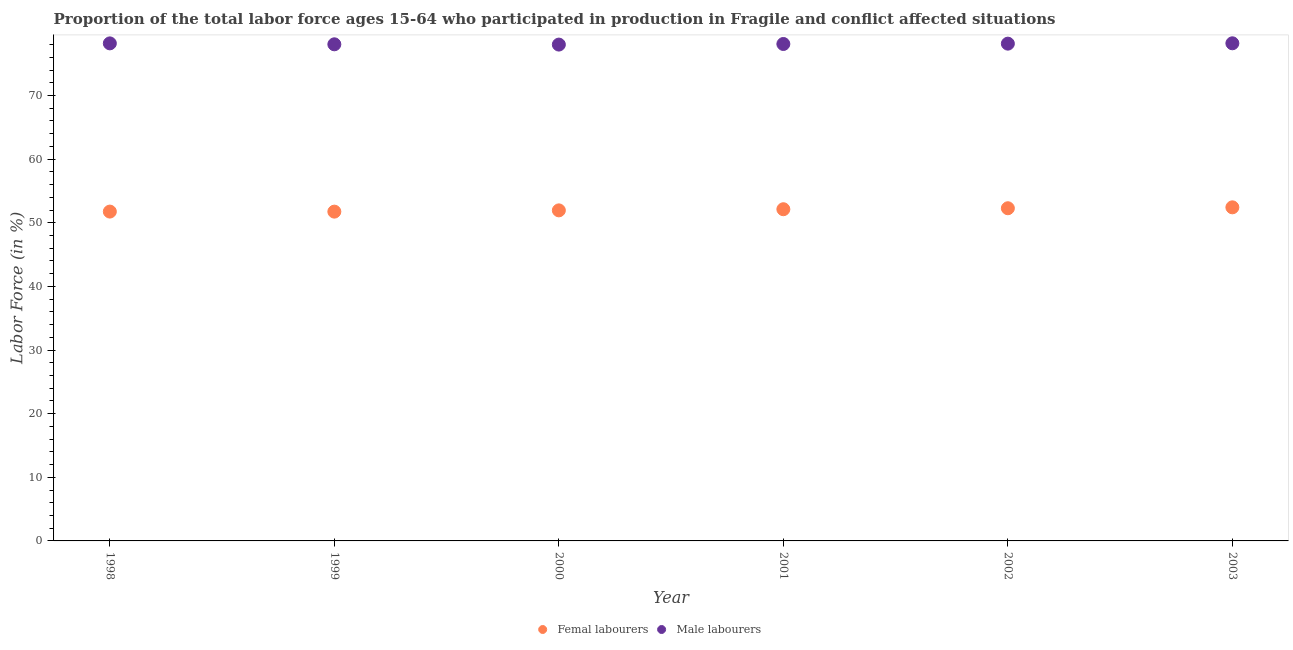Is the number of dotlines equal to the number of legend labels?
Offer a terse response. Yes. What is the percentage of female labor force in 1998?
Ensure brevity in your answer.  51.76. Across all years, what is the maximum percentage of female labor force?
Your answer should be compact. 52.43. Across all years, what is the minimum percentage of female labor force?
Your response must be concise. 51.75. What is the total percentage of male labour force in the graph?
Offer a terse response. 468.72. What is the difference between the percentage of male labour force in 1999 and that in 2003?
Ensure brevity in your answer.  -0.16. What is the difference between the percentage of male labour force in 2002 and the percentage of female labor force in 1998?
Make the answer very short. 26.4. What is the average percentage of male labour force per year?
Your answer should be very brief. 78.12. In the year 1999, what is the difference between the percentage of male labour force and percentage of female labor force?
Your answer should be very brief. 26.3. What is the ratio of the percentage of male labour force in 1998 to that in 2001?
Give a very brief answer. 1. What is the difference between the highest and the second highest percentage of male labour force?
Offer a very short reply. 0.01. What is the difference between the highest and the lowest percentage of male labour force?
Provide a short and direct response. 0.2. In how many years, is the percentage of male labour force greater than the average percentage of male labour force taken over all years?
Your response must be concise. 3. How many dotlines are there?
Make the answer very short. 2. How many years are there in the graph?
Your answer should be compact. 6. Does the graph contain any zero values?
Provide a succinct answer. No. Does the graph contain grids?
Provide a short and direct response. No. Where does the legend appear in the graph?
Your response must be concise. Bottom center. What is the title of the graph?
Provide a succinct answer. Proportion of the total labor force ages 15-64 who participated in production in Fragile and conflict affected situations. What is the Labor Force (in %) in Femal labourers in 1998?
Your response must be concise. 51.76. What is the Labor Force (in %) in Male labourers in 1998?
Offer a terse response. 78.2. What is the Labor Force (in %) of Femal labourers in 1999?
Your response must be concise. 51.75. What is the Labor Force (in %) in Male labourers in 1999?
Provide a succinct answer. 78.05. What is the Labor Force (in %) of Femal labourers in 2000?
Keep it short and to the point. 51.95. What is the Labor Force (in %) in Male labourers in 2000?
Your answer should be very brief. 78.01. What is the Labor Force (in %) in Femal labourers in 2001?
Ensure brevity in your answer.  52.13. What is the Labor Force (in %) of Male labourers in 2001?
Give a very brief answer. 78.1. What is the Labor Force (in %) of Femal labourers in 2002?
Give a very brief answer. 52.29. What is the Labor Force (in %) in Male labourers in 2002?
Give a very brief answer. 78.16. What is the Labor Force (in %) of Femal labourers in 2003?
Give a very brief answer. 52.43. What is the Labor Force (in %) in Male labourers in 2003?
Offer a terse response. 78.21. Across all years, what is the maximum Labor Force (in %) in Femal labourers?
Make the answer very short. 52.43. Across all years, what is the maximum Labor Force (in %) in Male labourers?
Provide a succinct answer. 78.21. Across all years, what is the minimum Labor Force (in %) in Femal labourers?
Make the answer very short. 51.75. Across all years, what is the minimum Labor Force (in %) in Male labourers?
Provide a succinct answer. 78.01. What is the total Labor Force (in %) of Femal labourers in the graph?
Keep it short and to the point. 312.31. What is the total Labor Force (in %) of Male labourers in the graph?
Your answer should be very brief. 468.72. What is the difference between the Labor Force (in %) in Femal labourers in 1998 and that in 1999?
Provide a succinct answer. 0.01. What is the difference between the Labor Force (in %) in Male labourers in 1998 and that in 1999?
Give a very brief answer. 0.15. What is the difference between the Labor Force (in %) of Femal labourers in 1998 and that in 2000?
Keep it short and to the point. -0.19. What is the difference between the Labor Force (in %) in Male labourers in 1998 and that in 2000?
Make the answer very short. 0.19. What is the difference between the Labor Force (in %) of Femal labourers in 1998 and that in 2001?
Keep it short and to the point. -0.37. What is the difference between the Labor Force (in %) in Male labourers in 1998 and that in 2001?
Offer a very short reply. 0.1. What is the difference between the Labor Force (in %) in Femal labourers in 1998 and that in 2002?
Offer a terse response. -0.53. What is the difference between the Labor Force (in %) of Male labourers in 1998 and that in 2002?
Your response must be concise. 0.04. What is the difference between the Labor Force (in %) of Femal labourers in 1998 and that in 2003?
Provide a short and direct response. -0.67. What is the difference between the Labor Force (in %) of Male labourers in 1998 and that in 2003?
Offer a very short reply. -0.01. What is the difference between the Labor Force (in %) of Femal labourers in 1999 and that in 2000?
Your answer should be compact. -0.2. What is the difference between the Labor Force (in %) in Male labourers in 1999 and that in 2000?
Keep it short and to the point. 0.04. What is the difference between the Labor Force (in %) of Femal labourers in 1999 and that in 2001?
Your answer should be very brief. -0.38. What is the difference between the Labor Force (in %) in Male labourers in 1999 and that in 2001?
Keep it short and to the point. -0.05. What is the difference between the Labor Force (in %) of Femal labourers in 1999 and that in 2002?
Provide a short and direct response. -0.53. What is the difference between the Labor Force (in %) in Male labourers in 1999 and that in 2002?
Offer a very short reply. -0.1. What is the difference between the Labor Force (in %) in Femal labourers in 1999 and that in 2003?
Make the answer very short. -0.68. What is the difference between the Labor Force (in %) of Male labourers in 1999 and that in 2003?
Provide a short and direct response. -0.16. What is the difference between the Labor Force (in %) in Femal labourers in 2000 and that in 2001?
Offer a very short reply. -0.18. What is the difference between the Labor Force (in %) in Male labourers in 2000 and that in 2001?
Your answer should be compact. -0.09. What is the difference between the Labor Force (in %) of Femal labourers in 2000 and that in 2002?
Keep it short and to the point. -0.33. What is the difference between the Labor Force (in %) in Male labourers in 2000 and that in 2002?
Your response must be concise. -0.15. What is the difference between the Labor Force (in %) of Femal labourers in 2000 and that in 2003?
Provide a succinct answer. -0.48. What is the difference between the Labor Force (in %) of Male labourers in 2000 and that in 2003?
Make the answer very short. -0.2. What is the difference between the Labor Force (in %) in Femal labourers in 2001 and that in 2002?
Your response must be concise. -0.15. What is the difference between the Labor Force (in %) in Male labourers in 2001 and that in 2002?
Your answer should be very brief. -0.05. What is the difference between the Labor Force (in %) in Femal labourers in 2001 and that in 2003?
Keep it short and to the point. -0.3. What is the difference between the Labor Force (in %) in Male labourers in 2001 and that in 2003?
Make the answer very short. -0.11. What is the difference between the Labor Force (in %) of Femal labourers in 2002 and that in 2003?
Offer a terse response. -0.14. What is the difference between the Labor Force (in %) in Male labourers in 2002 and that in 2003?
Give a very brief answer. -0.05. What is the difference between the Labor Force (in %) in Femal labourers in 1998 and the Labor Force (in %) in Male labourers in 1999?
Provide a succinct answer. -26.29. What is the difference between the Labor Force (in %) in Femal labourers in 1998 and the Labor Force (in %) in Male labourers in 2000?
Keep it short and to the point. -26.25. What is the difference between the Labor Force (in %) in Femal labourers in 1998 and the Labor Force (in %) in Male labourers in 2001?
Ensure brevity in your answer.  -26.34. What is the difference between the Labor Force (in %) in Femal labourers in 1998 and the Labor Force (in %) in Male labourers in 2002?
Give a very brief answer. -26.4. What is the difference between the Labor Force (in %) in Femal labourers in 1998 and the Labor Force (in %) in Male labourers in 2003?
Ensure brevity in your answer.  -26.45. What is the difference between the Labor Force (in %) of Femal labourers in 1999 and the Labor Force (in %) of Male labourers in 2000?
Give a very brief answer. -26.25. What is the difference between the Labor Force (in %) in Femal labourers in 1999 and the Labor Force (in %) in Male labourers in 2001?
Offer a very short reply. -26.35. What is the difference between the Labor Force (in %) in Femal labourers in 1999 and the Labor Force (in %) in Male labourers in 2002?
Your answer should be compact. -26.4. What is the difference between the Labor Force (in %) in Femal labourers in 1999 and the Labor Force (in %) in Male labourers in 2003?
Your answer should be very brief. -26.46. What is the difference between the Labor Force (in %) of Femal labourers in 2000 and the Labor Force (in %) of Male labourers in 2001?
Your answer should be very brief. -26.15. What is the difference between the Labor Force (in %) of Femal labourers in 2000 and the Labor Force (in %) of Male labourers in 2002?
Make the answer very short. -26.2. What is the difference between the Labor Force (in %) in Femal labourers in 2000 and the Labor Force (in %) in Male labourers in 2003?
Ensure brevity in your answer.  -26.26. What is the difference between the Labor Force (in %) in Femal labourers in 2001 and the Labor Force (in %) in Male labourers in 2002?
Provide a short and direct response. -26.02. What is the difference between the Labor Force (in %) of Femal labourers in 2001 and the Labor Force (in %) of Male labourers in 2003?
Offer a very short reply. -26.08. What is the difference between the Labor Force (in %) in Femal labourers in 2002 and the Labor Force (in %) in Male labourers in 2003?
Give a very brief answer. -25.93. What is the average Labor Force (in %) in Femal labourers per year?
Give a very brief answer. 52.05. What is the average Labor Force (in %) in Male labourers per year?
Your response must be concise. 78.12. In the year 1998, what is the difference between the Labor Force (in %) of Femal labourers and Labor Force (in %) of Male labourers?
Make the answer very short. -26.44. In the year 1999, what is the difference between the Labor Force (in %) in Femal labourers and Labor Force (in %) in Male labourers?
Make the answer very short. -26.3. In the year 2000, what is the difference between the Labor Force (in %) of Femal labourers and Labor Force (in %) of Male labourers?
Ensure brevity in your answer.  -26.06. In the year 2001, what is the difference between the Labor Force (in %) of Femal labourers and Labor Force (in %) of Male labourers?
Keep it short and to the point. -25.97. In the year 2002, what is the difference between the Labor Force (in %) of Femal labourers and Labor Force (in %) of Male labourers?
Ensure brevity in your answer.  -25.87. In the year 2003, what is the difference between the Labor Force (in %) in Femal labourers and Labor Force (in %) in Male labourers?
Keep it short and to the point. -25.78. What is the ratio of the Labor Force (in %) of Male labourers in 1998 to that in 1999?
Keep it short and to the point. 1. What is the ratio of the Labor Force (in %) of Femal labourers in 1998 to that in 2000?
Offer a very short reply. 1. What is the ratio of the Labor Force (in %) of Femal labourers in 1998 to that in 2003?
Your answer should be compact. 0.99. What is the ratio of the Labor Force (in %) of Male labourers in 1998 to that in 2003?
Ensure brevity in your answer.  1. What is the ratio of the Labor Force (in %) of Femal labourers in 1999 to that in 2000?
Make the answer very short. 1. What is the ratio of the Labor Force (in %) of Male labourers in 1999 to that in 2002?
Ensure brevity in your answer.  1. What is the ratio of the Labor Force (in %) of Femal labourers in 1999 to that in 2003?
Offer a terse response. 0.99. What is the ratio of the Labor Force (in %) in Male labourers in 2000 to that in 2001?
Keep it short and to the point. 1. What is the ratio of the Labor Force (in %) of Male labourers in 2000 to that in 2002?
Make the answer very short. 1. What is the ratio of the Labor Force (in %) of Femal labourers in 2000 to that in 2003?
Make the answer very short. 0.99. What is the ratio of the Labor Force (in %) in Femal labourers in 2001 to that in 2002?
Your answer should be compact. 1. What is the ratio of the Labor Force (in %) of Male labourers in 2001 to that in 2002?
Offer a very short reply. 1. What is the ratio of the Labor Force (in %) in Femal labourers in 2001 to that in 2003?
Ensure brevity in your answer.  0.99. What is the ratio of the Labor Force (in %) of Femal labourers in 2002 to that in 2003?
Your response must be concise. 1. What is the difference between the highest and the second highest Labor Force (in %) in Femal labourers?
Provide a short and direct response. 0.14. What is the difference between the highest and the second highest Labor Force (in %) in Male labourers?
Keep it short and to the point. 0.01. What is the difference between the highest and the lowest Labor Force (in %) of Femal labourers?
Give a very brief answer. 0.68. What is the difference between the highest and the lowest Labor Force (in %) in Male labourers?
Your answer should be very brief. 0.2. 